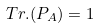<formula> <loc_0><loc_0><loc_500><loc_500>T r . ( P _ { A } ) = 1</formula> 